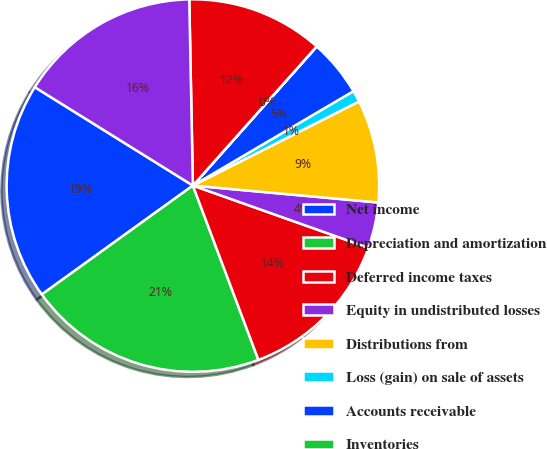<chart> <loc_0><loc_0><loc_500><loc_500><pie_chart><fcel>Net income<fcel>Depreciation and amortization<fcel>Deferred income taxes<fcel>Equity in undistributed losses<fcel>Distributions from<fcel>Loss (gain) on sale of assets<fcel>Accounts receivable<fcel>Inventories<fcel>Other current assets<fcel>Accounts payable and accrued<nl><fcel>18.8%<fcel>20.78%<fcel>13.86%<fcel>3.97%<fcel>8.91%<fcel>1.0%<fcel>4.96%<fcel>0.01%<fcel>11.88%<fcel>15.83%<nl></chart> 